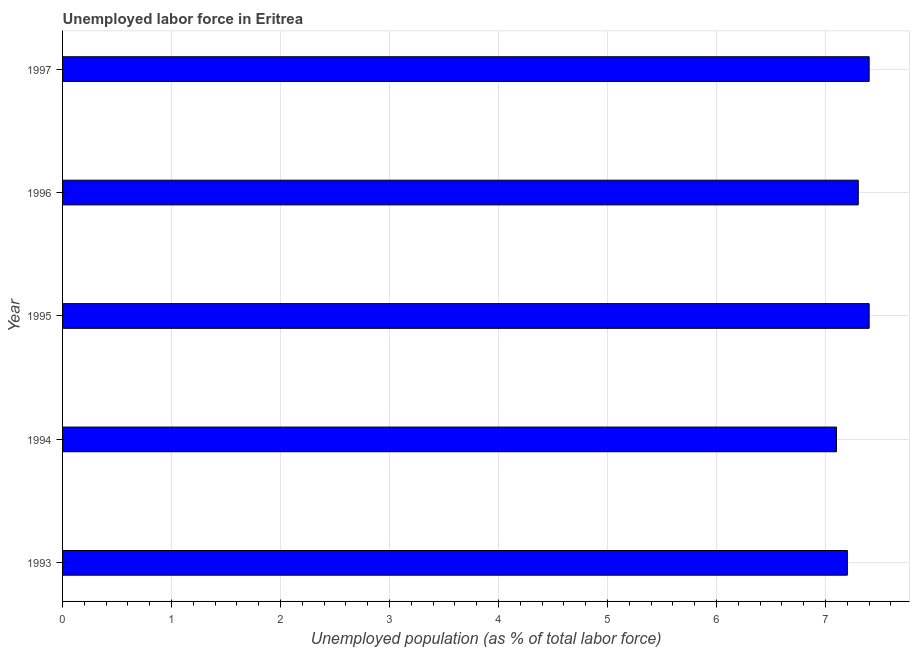Does the graph contain any zero values?
Keep it short and to the point. No. What is the title of the graph?
Make the answer very short. Unemployed labor force in Eritrea. What is the label or title of the X-axis?
Make the answer very short. Unemployed population (as % of total labor force). What is the label or title of the Y-axis?
Provide a succinct answer. Year. What is the total unemployed population in 1996?
Offer a very short reply. 7.3. Across all years, what is the maximum total unemployed population?
Your answer should be very brief. 7.4. Across all years, what is the minimum total unemployed population?
Your response must be concise. 7.1. In which year was the total unemployed population maximum?
Provide a succinct answer. 1995. What is the sum of the total unemployed population?
Make the answer very short. 36.4. What is the average total unemployed population per year?
Make the answer very short. 7.28. What is the median total unemployed population?
Make the answer very short. 7.3. Do a majority of the years between 1993 and 1997 (inclusive) have total unemployed population greater than 4 %?
Make the answer very short. Yes. In how many years, is the total unemployed population greater than the average total unemployed population taken over all years?
Keep it short and to the point. 3. How many bars are there?
Offer a very short reply. 5. Are all the bars in the graph horizontal?
Provide a short and direct response. Yes. How many years are there in the graph?
Your answer should be compact. 5. Are the values on the major ticks of X-axis written in scientific E-notation?
Provide a short and direct response. No. What is the Unemployed population (as % of total labor force) in 1993?
Your response must be concise. 7.2. What is the Unemployed population (as % of total labor force) of 1994?
Your answer should be very brief. 7.1. What is the Unemployed population (as % of total labor force) in 1995?
Your answer should be compact. 7.4. What is the Unemployed population (as % of total labor force) of 1996?
Offer a very short reply. 7.3. What is the Unemployed population (as % of total labor force) of 1997?
Offer a terse response. 7.4. What is the difference between the Unemployed population (as % of total labor force) in 1993 and 1994?
Keep it short and to the point. 0.1. What is the difference between the Unemployed population (as % of total labor force) in 1993 and 1995?
Give a very brief answer. -0.2. What is the difference between the Unemployed population (as % of total labor force) in 1994 and 1995?
Give a very brief answer. -0.3. What is the difference between the Unemployed population (as % of total labor force) in 1994 and 1996?
Your response must be concise. -0.2. What is the difference between the Unemployed population (as % of total labor force) in 1995 and 1996?
Your answer should be compact. 0.1. What is the difference between the Unemployed population (as % of total labor force) in 1996 and 1997?
Provide a short and direct response. -0.1. What is the ratio of the Unemployed population (as % of total labor force) in 1993 to that in 1994?
Offer a terse response. 1.01. What is the ratio of the Unemployed population (as % of total labor force) in 1994 to that in 1996?
Offer a very short reply. 0.97. What is the ratio of the Unemployed population (as % of total labor force) in 1994 to that in 1997?
Your response must be concise. 0.96. What is the ratio of the Unemployed population (as % of total labor force) in 1996 to that in 1997?
Provide a short and direct response. 0.99. 